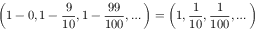<formula> <loc_0><loc_0><loc_500><loc_500>\left ( 1 - 0 , 1 - { \frac { 9 } { 1 0 } } , 1 - { \frac { 9 9 } { 1 0 0 } } , \dots \right ) = \left ( 1 , { \frac { 1 } { 1 0 } } , { \frac { 1 } { 1 0 0 } } , \dots \right )</formula> 